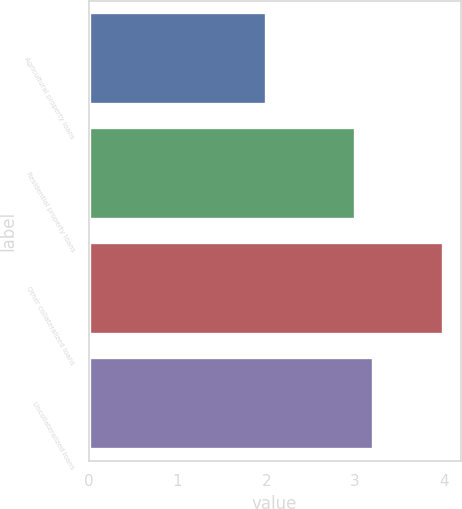<chart> <loc_0><loc_0><loc_500><loc_500><bar_chart><fcel>Agricultural property loans<fcel>Residential property loans<fcel>Other collateralized loans<fcel>Uncollateralized loans<nl><fcel>2<fcel>3<fcel>3.99<fcel>3.2<nl></chart> 